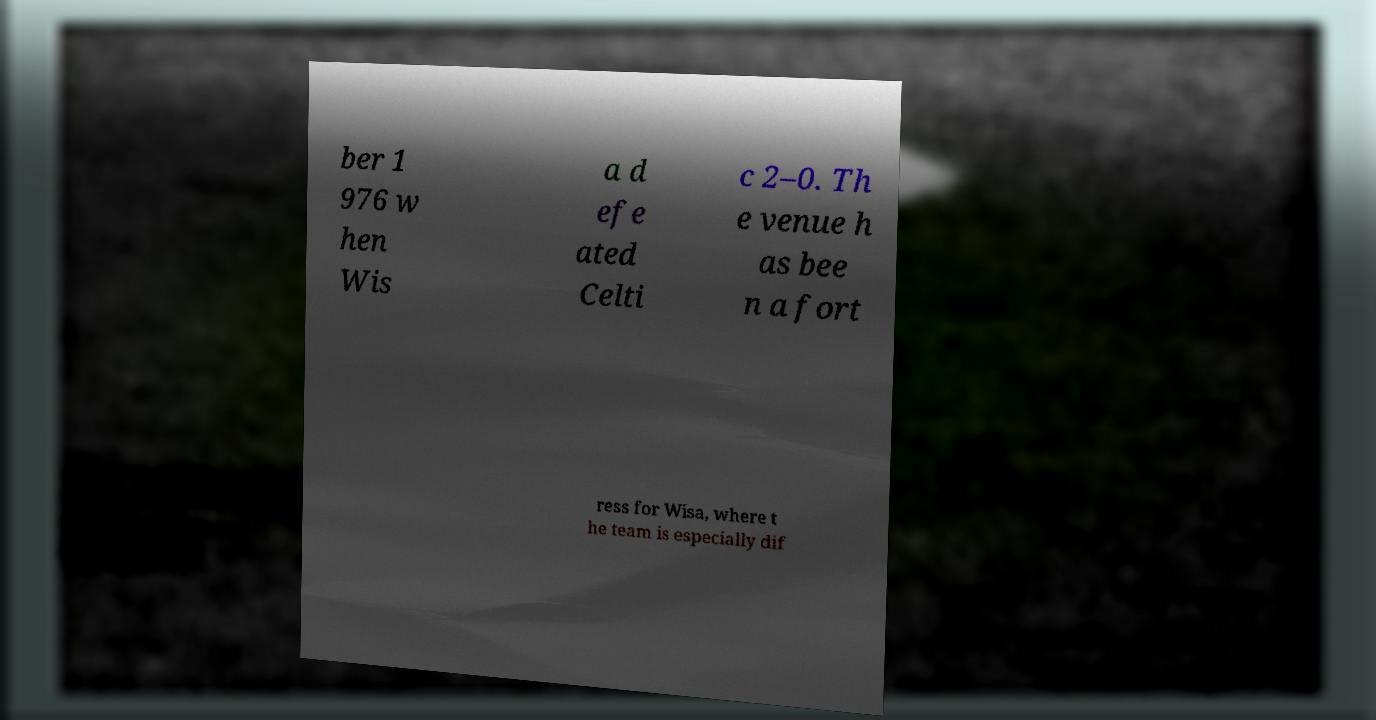Can you read and provide the text displayed in the image?This photo seems to have some interesting text. Can you extract and type it out for me? ber 1 976 w hen Wis a d efe ated Celti c 2–0. Th e venue h as bee n a fort ress for Wisa, where t he team is especially dif 